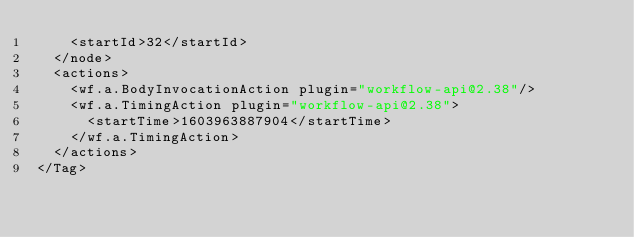<code> <loc_0><loc_0><loc_500><loc_500><_XML_>    <startId>32</startId>
  </node>
  <actions>
    <wf.a.BodyInvocationAction plugin="workflow-api@2.38"/>
    <wf.a.TimingAction plugin="workflow-api@2.38">
      <startTime>1603963887904</startTime>
    </wf.a.TimingAction>
  </actions>
</Tag></code> 